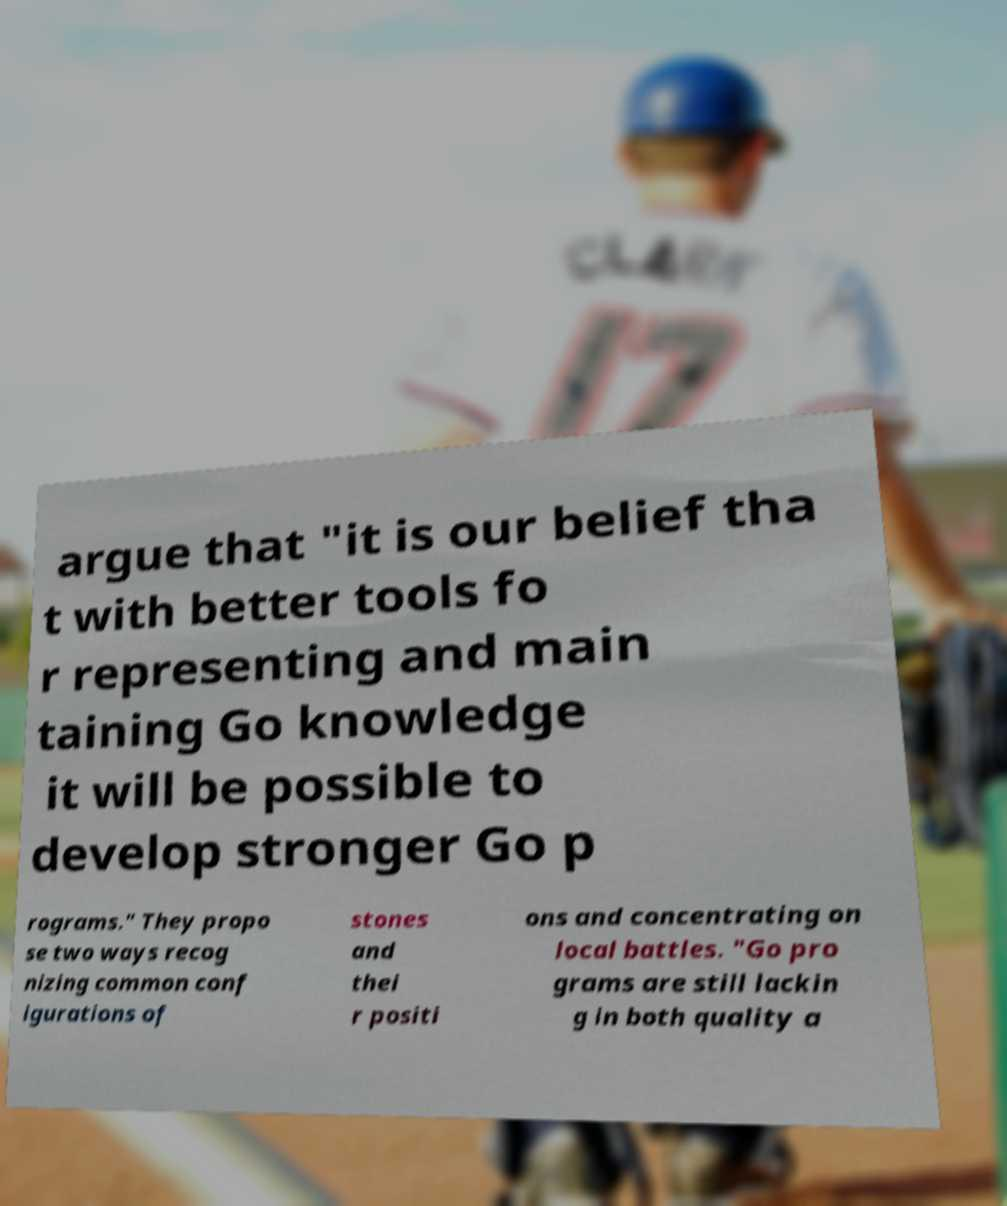Could you assist in decoding the text presented in this image and type it out clearly? argue that "it is our belief tha t with better tools fo r representing and main taining Go knowledge it will be possible to develop stronger Go p rograms." They propo se two ways recog nizing common conf igurations of stones and thei r positi ons and concentrating on local battles. "Go pro grams are still lackin g in both quality a 